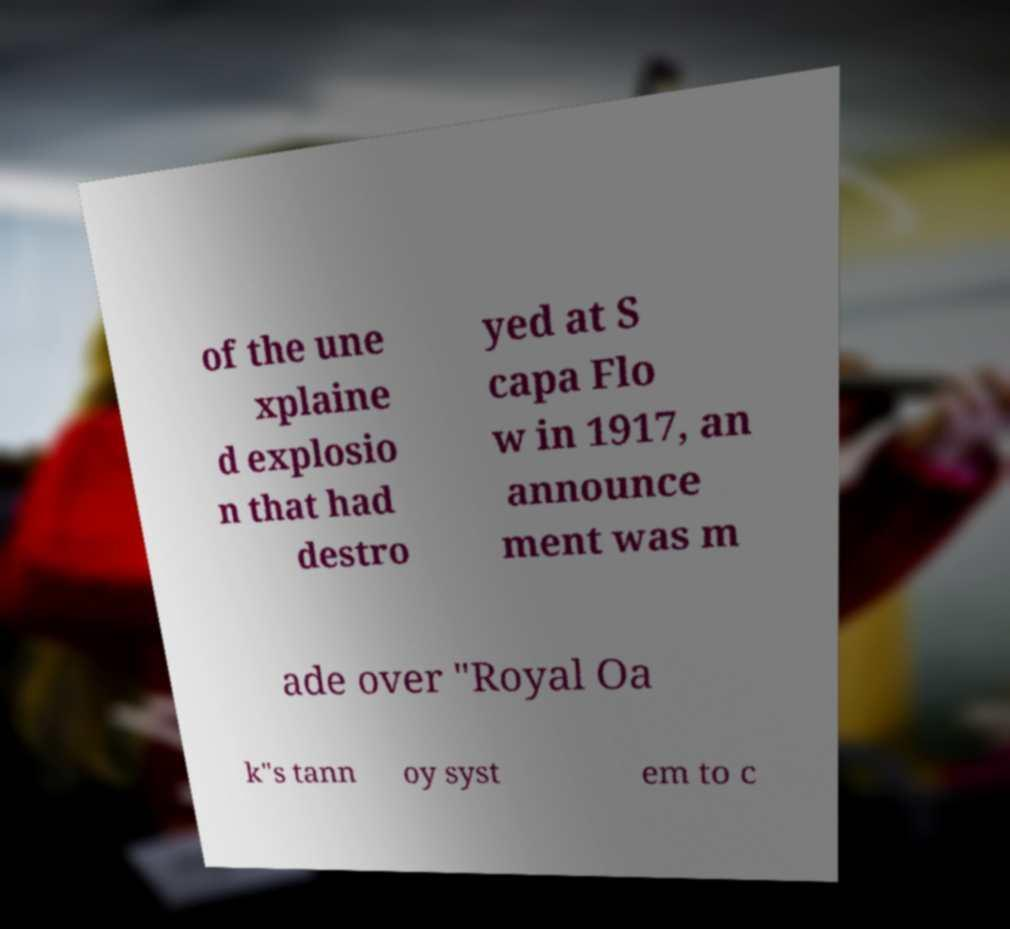Please read and relay the text visible in this image. What does it say? of the une xplaine d explosio n that had destro yed at S capa Flo w in 1917, an announce ment was m ade over "Royal Oa k"s tann oy syst em to c 